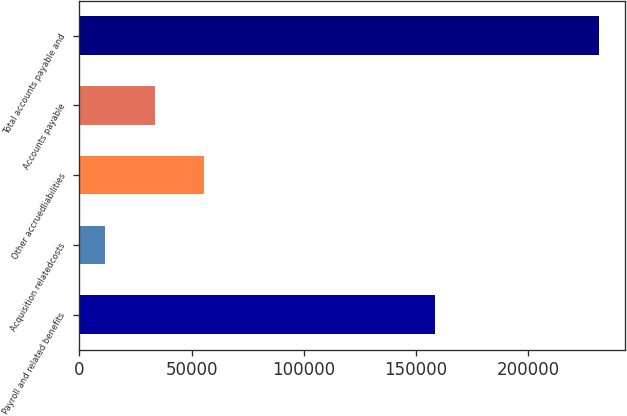Convert chart to OTSL. <chart><loc_0><loc_0><loc_500><loc_500><bar_chart><fcel>Payroll and related benefits<fcel>Acquisition relatedcosts<fcel>Other accruedliabilities<fcel>Accounts payable<fcel>Total accounts payable and<nl><fcel>158507<fcel>11592<fcel>55545.4<fcel>33568.7<fcel>231359<nl></chart> 